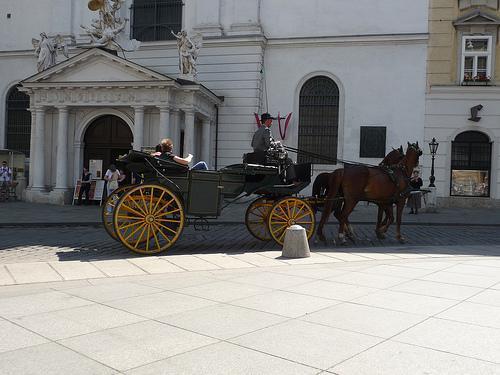How many horses are in the picture?
Give a very brief answer. 2. 